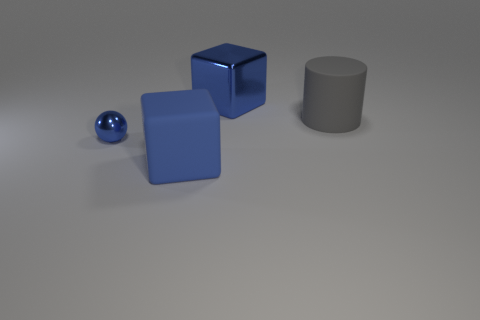Add 1 large blue matte cubes. How many objects exist? 5 Subtract all balls. How many objects are left? 3 Subtract all big blue rubber cubes. Subtract all big blocks. How many objects are left? 1 Add 2 big gray matte objects. How many big gray matte objects are left? 3 Add 4 green rubber cylinders. How many green rubber cylinders exist? 4 Subtract 0 gray spheres. How many objects are left? 4 